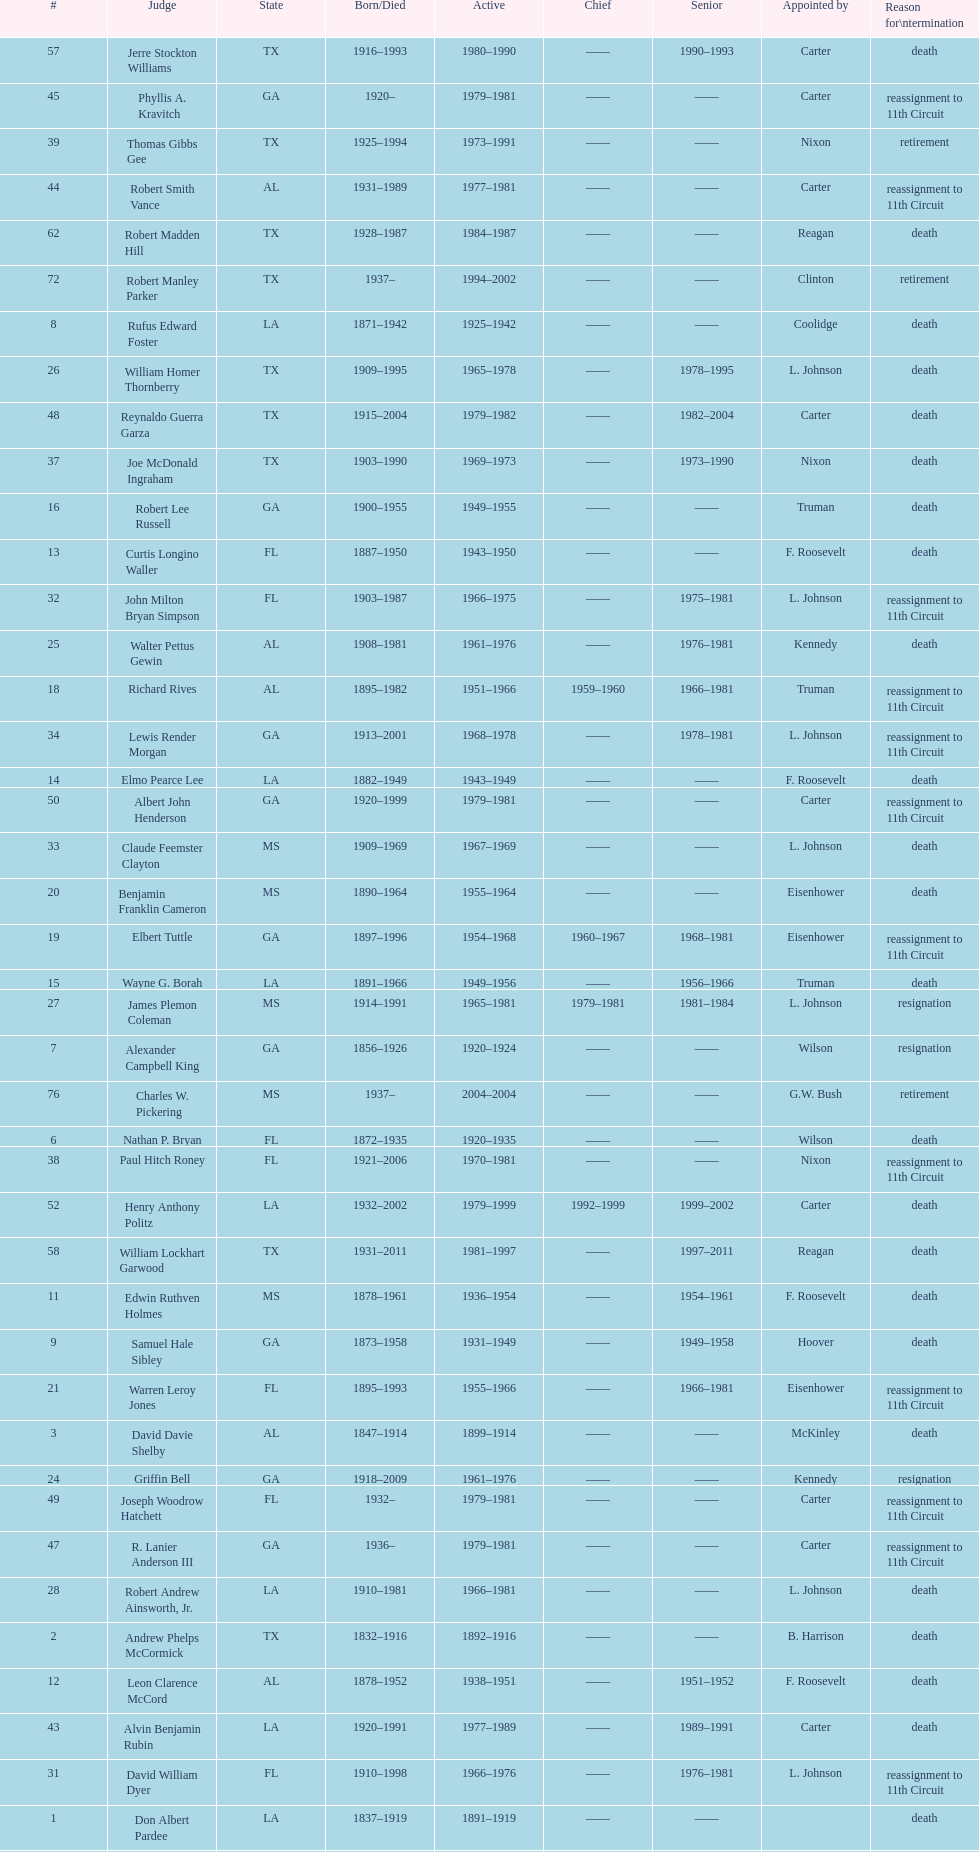Who was the next judge to resign after alexander campbell king? Griffin Bell. 